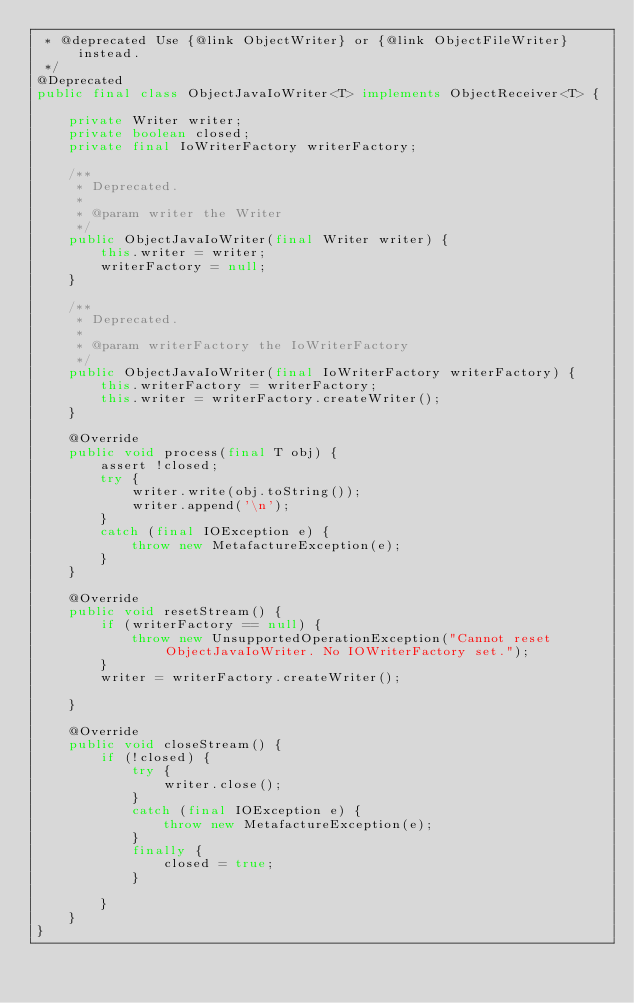<code> <loc_0><loc_0><loc_500><loc_500><_Java_> * @deprecated Use {@link ObjectWriter} or {@link ObjectFileWriter} instead.
 */
@Deprecated
public final class ObjectJavaIoWriter<T> implements ObjectReceiver<T> {

    private Writer writer;
    private boolean closed;
    private final IoWriterFactory writerFactory;

    /**
     * Deprecated.
     *
     * @param writer the Writer
     */
    public ObjectJavaIoWriter(final Writer writer) {
        this.writer = writer;
        writerFactory = null;
    }

    /**
     * Deprecated.
     *
     * @param writerFactory the IoWriterFactory
     */
    public ObjectJavaIoWriter(final IoWriterFactory writerFactory) {
        this.writerFactory = writerFactory;
        this.writer = writerFactory.createWriter();
    }

    @Override
    public void process(final T obj) {
        assert !closed;
        try {
            writer.write(obj.toString());
            writer.append('\n');
        }
        catch (final IOException e) {
            throw new MetafactureException(e);
        }
    }

    @Override
    public void resetStream() {
        if (writerFactory == null) {
            throw new UnsupportedOperationException("Cannot reset ObjectJavaIoWriter. No IOWriterFactory set.");
        }
        writer = writerFactory.createWriter();

    }

    @Override
    public void closeStream() {
        if (!closed) {
            try {
                writer.close();
            }
            catch (final IOException e) {
                throw new MetafactureException(e);
            }
            finally {
                closed = true;
            }

        }
    }
}
</code> 